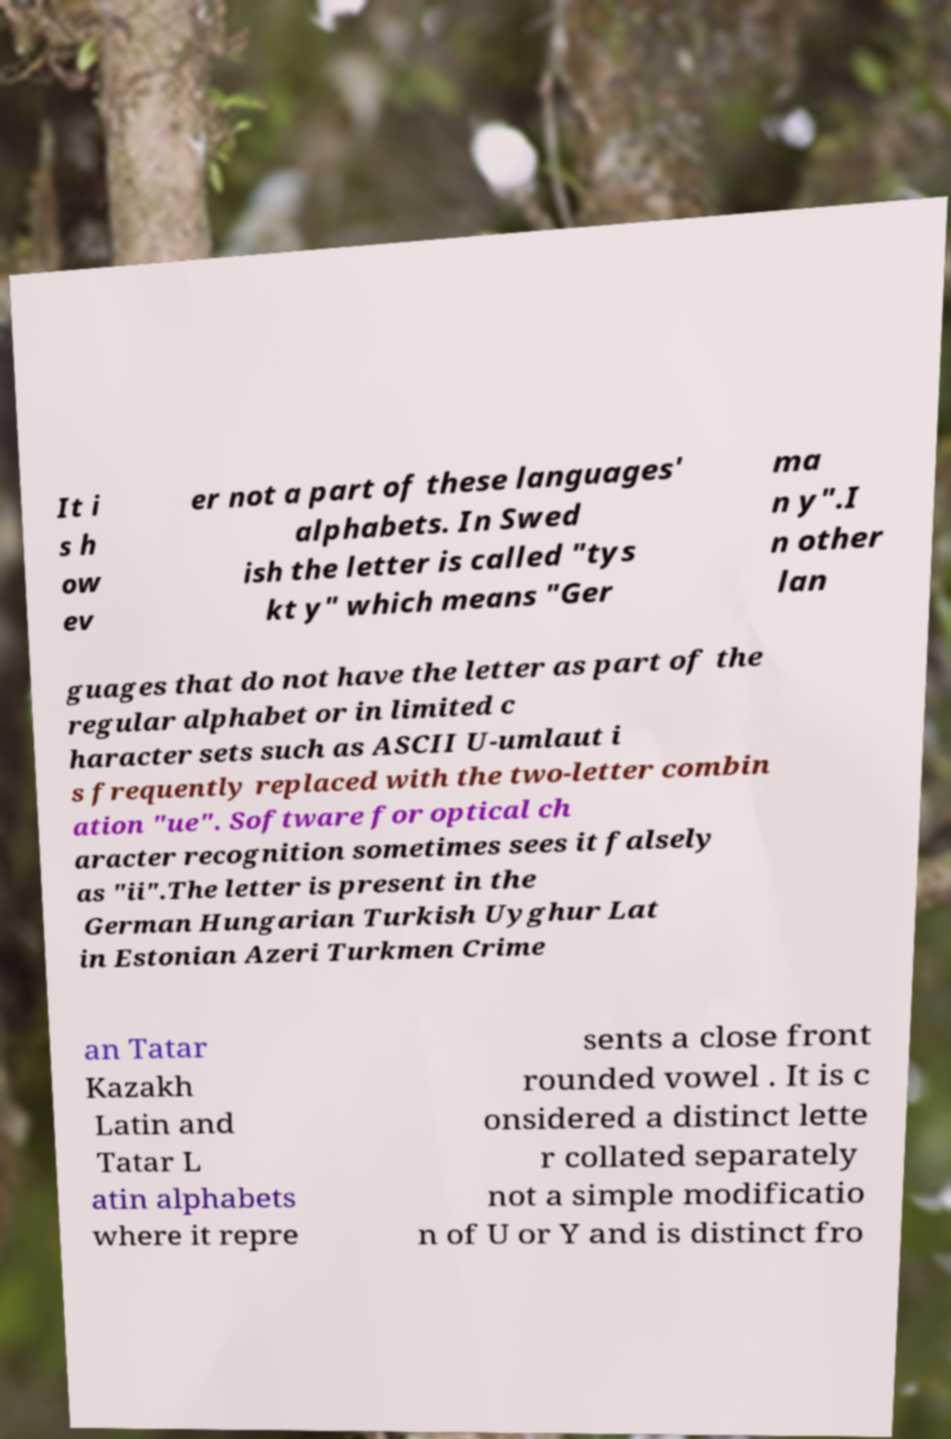Can you accurately transcribe the text from the provided image for me? It i s h ow ev er not a part of these languages' alphabets. In Swed ish the letter is called "tys kt y" which means "Ger ma n y".I n other lan guages that do not have the letter as part of the regular alphabet or in limited c haracter sets such as ASCII U-umlaut i s frequently replaced with the two-letter combin ation "ue". Software for optical ch aracter recognition sometimes sees it falsely as "ii".The letter is present in the German Hungarian Turkish Uyghur Lat in Estonian Azeri Turkmen Crime an Tatar Kazakh Latin and Tatar L atin alphabets where it repre sents a close front rounded vowel . It is c onsidered a distinct lette r collated separately not a simple modificatio n of U or Y and is distinct fro 